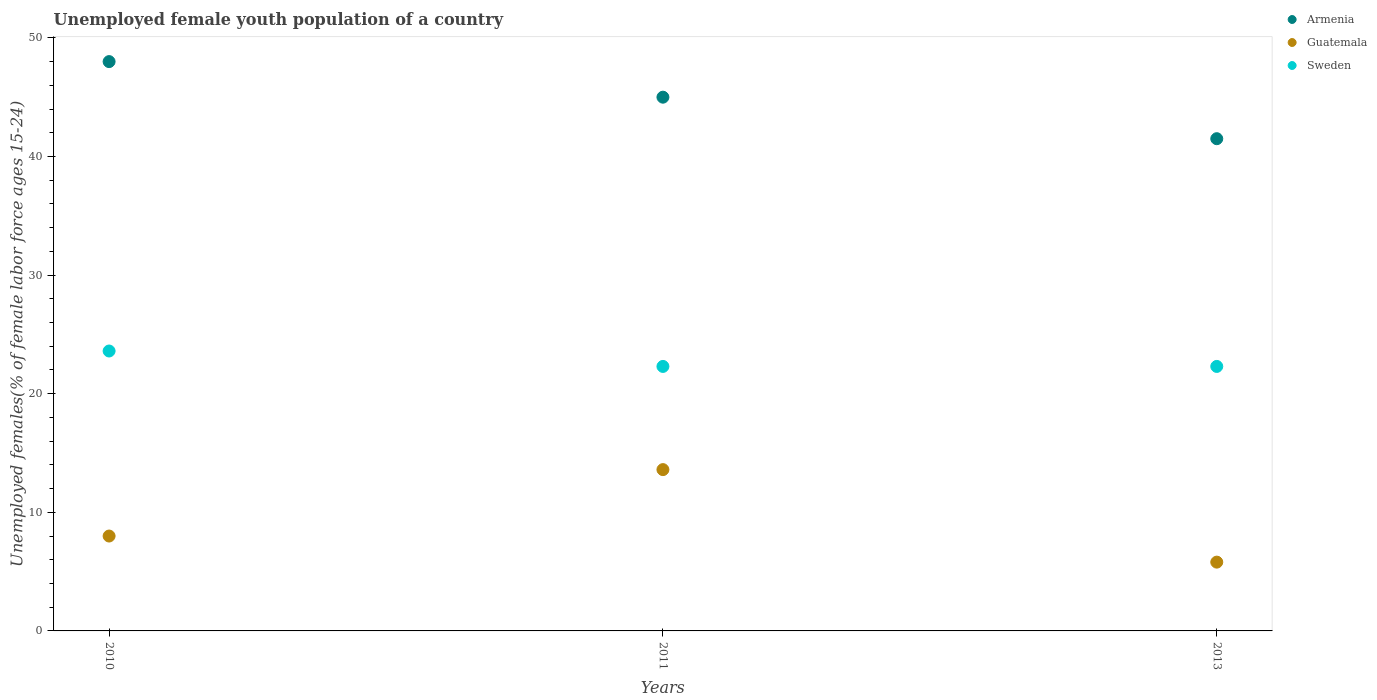Is the number of dotlines equal to the number of legend labels?
Ensure brevity in your answer.  Yes. What is the percentage of unemployed female youth population in Guatemala in 2011?
Your response must be concise. 13.6. Across all years, what is the maximum percentage of unemployed female youth population in Guatemala?
Your answer should be very brief. 13.6. Across all years, what is the minimum percentage of unemployed female youth population in Guatemala?
Your response must be concise. 5.8. In which year was the percentage of unemployed female youth population in Sweden minimum?
Your answer should be compact. 2011. What is the total percentage of unemployed female youth population in Guatemala in the graph?
Your answer should be compact. 27.4. What is the difference between the percentage of unemployed female youth population in Sweden in 2010 and that in 2013?
Provide a short and direct response. 1.3. What is the difference between the percentage of unemployed female youth population in Guatemala in 2011 and the percentage of unemployed female youth population in Armenia in 2013?
Provide a succinct answer. -27.9. What is the average percentage of unemployed female youth population in Sweden per year?
Your response must be concise. 22.73. In the year 2013, what is the difference between the percentage of unemployed female youth population in Sweden and percentage of unemployed female youth population in Guatemala?
Provide a short and direct response. 16.5. What is the ratio of the percentage of unemployed female youth population in Sweden in 2010 to that in 2011?
Offer a terse response. 1.06. Is the difference between the percentage of unemployed female youth population in Sweden in 2010 and 2011 greater than the difference between the percentage of unemployed female youth population in Guatemala in 2010 and 2011?
Offer a very short reply. Yes. What is the difference between the highest and the second highest percentage of unemployed female youth population in Sweden?
Ensure brevity in your answer.  1.3. Is the sum of the percentage of unemployed female youth population in Sweden in 2010 and 2011 greater than the maximum percentage of unemployed female youth population in Guatemala across all years?
Ensure brevity in your answer.  Yes. Is it the case that in every year, the sum of the percentage of unemployed female youth population in Armenia and percentage of unemployed female youth population in Sweden  is greater than the percentage of unemployed female youth population in Guatemala?
Your answer should be compact. Yes. Does the percentage of unemployed female youth population in Guatemala monotonically increase over the years?
Offer a terse response. No. Is the percentage of unemployed female youth population in Sweden strictly greater than the percentage of unemployed female youth population in Armenia over the years?
Your answer should be very brief. No. Is the percentage of unemployed female youth population in Sweden strictly less than the percentage of unemployed female youth population in Armenia over the years?
Ensure brevity in your answer.  Yes. How many dotlines are there?
Provide a succinct answer. 3. Are the values on the major ticks of Y-axis written in scientific E-notation?
Your answer should be very brief. No. Does the graph contain any zero values?
Your answer should be compact. No. Where does the legend appear in the graph?
Provide a short and direct response. Top right. How are the legend labels stacked?
Ensure brevity in your answer.  Vertical. What is the title of the graph?
Keep it short and to the point. Unemployed female youth population of a country. What is the label or title of the X-axis?
Provide a short and direct response. Years. What is the label or title of the Y-axis?
Offer a terse response. Unemployed females(% of female labor force ages 15-24). What is the Unemployed females(% of female labor force ages 15-24) in Armenia in 2010?
Provide a short and direct response. 48. What is the Unemployed females(% of female labor force ages 15-24) in Guatemala in 2010?
Ensure brevity in your answer.  8. What is the Unemployed females(% of female labor force ages 15-24) in Sweden in 2010?
Ensure brevity in your answer.  23.6. What is the Unemployed females(% of female labor force ages 15-24) of Guatemala in 2011?
Your response must be concise. 13.6. What is the Unemployed females(% of female labor force ages 15-24) of Sweden in 2011?
Provide a succinct answer. 22.3. What is the Unemployed females(% of female labor force ages 15-24) in Armenia in 2013?
Make the answer very short. 41.5. What is the Unemployed females(% of female labor force ages 15-24) of Guatemala in 2013?
Offer a very short reply. 5.8. What is the Unemployed females(% of female labor force ages 15-24) in Sweden in 2013?
Offer a terse response. 22.3. Across all years, what is the maximum Unemployed females(% of female labor force ages 15-24) in Guatemala?
Offer a very short reply. 13.6. Across all years, what is the maximum Unemployed females(% of female labor force ages 15-24) in Sweden?
Offer a very short reply. 23.6. Across all years, what is the minimum Unemployed females(% of female labor force ages 15-24) of Armenia?
Provide a short and direct response. 41.5. Across all years, what is the minimum Unemployed females(% of female labor force ages 15-24) of Guatemala?
Your response must be concise. 5.8. Across all years, what is the minimum Unemployed females(% of female labor force ages 15-24) in Sweden?
Ensure brevity in your answer.  22.3. What is the total Unemployed females(% of female labor force ages 15-24) in Armenia in the graph?
Ensure brevity in your answer.  134.5. What is the total Unemployed females(% of female labor force ages 15-24) in Guatemala in the graph?
Your answer should be compact. 27.4. What is the total Unemployed females(% of female labor force ages 15-24) of Sweden in the graph?
Offer a terse response. 68.2. What is the difference between the Unemployed females(% of female labor force ages 15-24) of Armenia in 2010 and that in 2011?
Make the answer very short. 3. What is the difference between the Unemployed females(% of female labor force ages 15-24) of Armenia in 2010 and that in 2013?
Give a very brief answer. 6.5. What is the difference between the Unemployed females(% of female labor force ages 15-24) of Guatemala in 2010 and that in 2013?
Provide a short and direct response. 2.2. What is the difference between the Unemployed females(% of female labor force ages 15-24) of Sweden in 2010 and that in 2013?
Make the answer very short. 1.3. What is the difference between the Unemployed females(% of female labor force ages 15-24) of Armenia in 2011 and that in 2013?
Offer a terse response. 3.5. What is the difference between the Unemployed females(% of female labor force ages 15-24) in Sweden in 2011 and that in 2013?
Offer a very short reply. 0. What is the difference between the Unemployed females(% of female labor force ages 15-24) of Armenia in 2010 and the Unemployed females(% of female labor force ages 15-24) of Guatemala in 2011?
Ensure brevity in your answer.  34.4. What is the difference between the Unemployed females(% of female labor force ages 15-24) in Armenia in 2010 and the Unemployed females(% of female labor force ages 15-24) in Sweden in 2011?
Offer a very short reply. 25.7. What is the difference between the Unemployed females(% of female labor force ages 15-24) of Guatemala in 2010 and the Unemployed females(% of female labor force ages 15-24) of Sweden in 2011?
Give a very brief answer. -14.3. What is the difference between the Unemployed females(% of female labor force ages 15-24) in Armenia in 2010 and the Unemployed females(% of female labor force ages 15-24) in Guatemala in 2013?
Provide a succinct answer. 42.2. What is the difference between the Unemployed females(% of female labor force ages 15-24) of Armenia in 2010 and the Unemployed females(% of female labor force ages 15-24) of Sweden in 2013?
Offer a very short reply. 25.7. What is the difference between the Unemployed females(% of female labor force ages 15-24) in Guatemala in 2010 and the Unemployed females(% of female labor force ages 15-24) in Sweden in 2013?
Ensure brevity in your answer.  -14.3. What is the difference between the Unemployed females(% of female labor force ages 15-24) of Armenia in 2011 and the Unemployed females(% of female labor force ages 15-24) of Guatemala in 2013?
Keep it short and to the point. 39.2. What is the difference between the Unemployed females(% of female labor force ages 15-24) in Armenia in 2011 and the Unemployed females(% of female labor force ages 15-24) in Sweden in 2013?
Your answer should be compact. 22.7. What is the average Unemployed females(% of female labor force ages 15-24) in Armenia per year?
Offer a very short reply. 44.83. What is the average Unemployed females(% of female labor force ages 15-24) of Guatemala per year?
Provide a succinct answer. 9.13. What is the average Unemployed females(% of female labor force ages 15-24) in Sweden per year?
Make the answer very short. 22.73. In the year 2010, what is the difference between the Unemployed females(% of female labor force ages 15-24) in Armenia and Unemployed females(% of female labor force ages 15-24) in Guatemala?
Offer a terse response. 40. In the year 2010, what is the difference between the Unemployed females(% of female labor force ages 15-24) in Armenia and Unemployed females(% of female labor force ages 15-24) in Sweden?
Your answer should be compact. 24.4. In the year 2010, what is the difference between the Unemployed females(% of female labor force ages 15-24) in Guatemala and Unemployed females(% of female labor force ages 15-24) in Sweden?
Ensure brevity in your answer.  -15.6. In the year 2011, what is the difference between the Unemployed females(% of female labor force ages 15-24) of Armenia and Unemployed females(% of female labor force ages 15-24) of Guatemala?
Make the answer very short. 31.4. In the year 2011, what is the difference between the Unemployed females(% of female labor force ages 15-24) in Armenia and Unemployed females(% of female labor force ages 15-24) in Sweden?
Your response must be concise. 22.7. In the year 2013, what is the difference between the Unemployed females(% of female labor force ages 15-24) in Armenia and Unemployed females(% of female labor force ages 15-24) in Guatemala?
Give a very brief answer. 35.7. In the year 2013, what is the difference between the Unemployed females(% of female labor force ages 15-24) in Armenia and Unemployed females(% of female labor force ages 15-24) in Sweden?
Provide a short and direct response. 19.2. In the year 2013, what is the difference between the Unemployed females(% of female labor force ages 15-24) of Guatemala and Unemployed females(% of female labor force ages 15-24) of Sweden?
Ensure brevity in your answer.  -16.5. What is the ratio of the Unemployed females(% of female labor force ages 15-24) of Armenia in 2010 to that in 2011?
Make the answer very short. 1.07. What is the ratio of the Unemployed females(% of female labor force ages 15-24) in Guatemala in 2010 to that in 2011?
Your response must be concise. 0.59. What is the ratio of the Unemployed females(% of female labor force ages 15-24) in Sweden in 2010 to that in 2011?
Offer a very short reply. 1.06. What is the ratio of the Unemployed females(% of female labor force ages 15-24) in Armenia in 2010 to that in 2013?
Keep it short and to the point. 1.16. What is the ratio of the Unemployed females(% of female labor force ages 15-24) of Guatemala in 2010 to that in 2013?
Ensure brevity in your answer.  1.38. What is the ratio of the Unemployed females(% of female labor force ages 15-24) in Sweden in 2010 to that in 2013?
Provide a succinct answer. 1.06. What is the ratio of the Unemployed females(% of female labor force ages 15-24) of Armenia in 2011 to that in 2013?
Provide a succinct answer. 1.08. What is the ratio of the Unemployed females(% of female labor force ages 15-24) of Guatemala in 2011 to that in 2013?
Offer a terse response. 2.34. What is the ratio of the Unemployed females(% of female labor force ages 15-24) in Sweden in 2011 to that in 2013?
Offer a very short reply. 1. What is the difference between the highest and the second highest Unemployed females(% of female labor force ages 15-24) in Armenia?
Offer a terse response. 3. What is the difference between the highest and the second highest Unemployed females(% of female labor force ages 15-24) of Guatemala?
Make the answer very short. 5.6. What is the difference between the highest and the second highest Unemployed females(% of female labor force ages 15-24) in Sweden?
Offer a very short reply. 1.3. What is the difference between the highest and the lowest Unemployed females(% of female labor force ages 15-24) of Guatemala?
Provide a short and direct response. 7.8. What is the difference between the highest and the lowest Unemployed females(% of female labor force ages 15-24) of Sweden?
Ensure brevity in your answer.  1.3. 